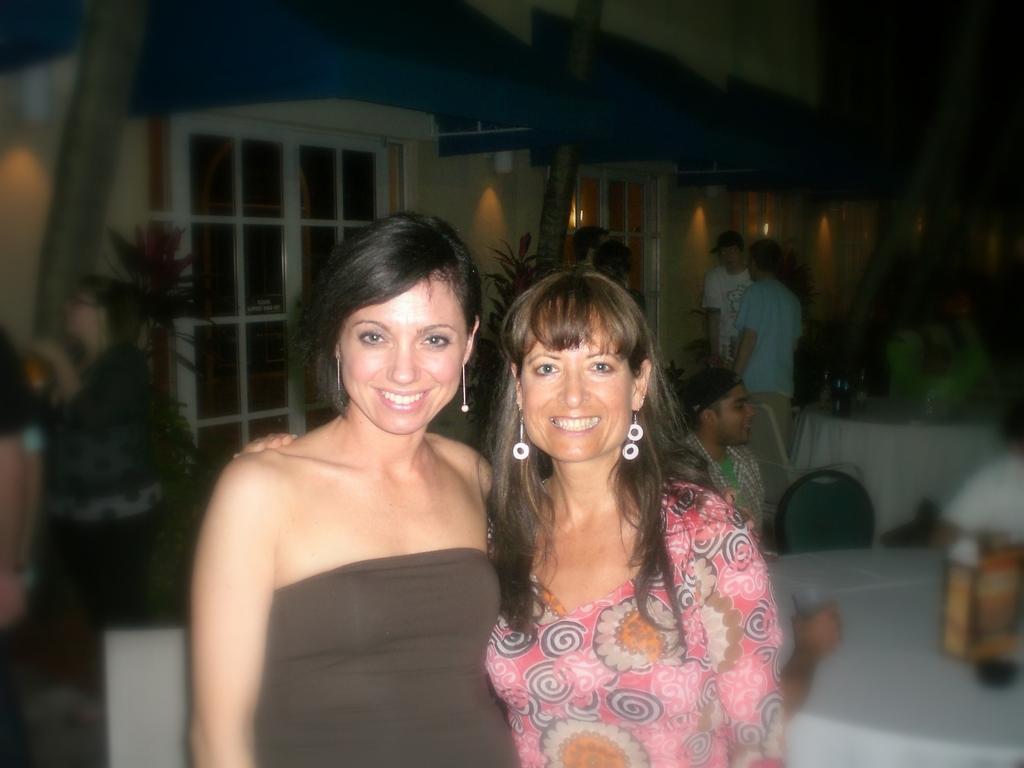Describe this image in one or two sentences. In this picture we can see two women,they are smiling and in the background we can see a table,people,house plants,wall. 